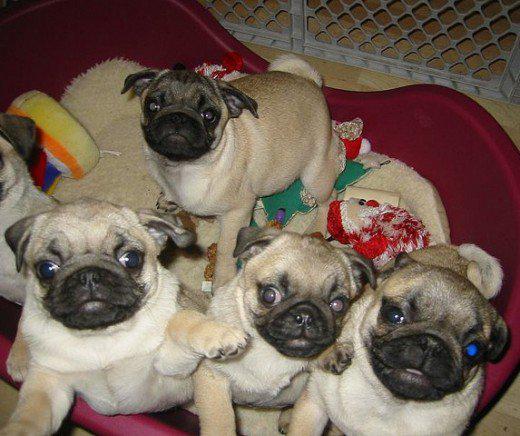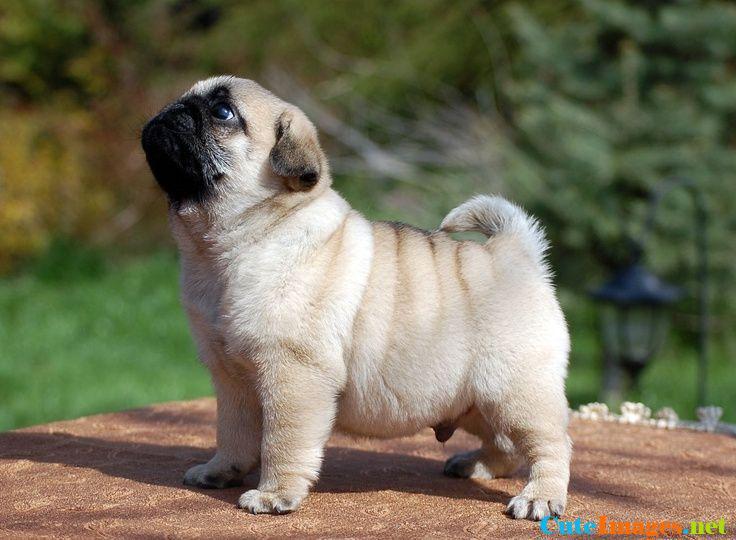The first image is the image on the left, the second image is the image on the right. Analyze the images presented: Is the assertion "One of the dogs is sitting on the grass." valid? Answer yes or no. No. 